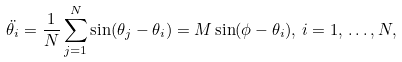<formula> <loc_0><loc_0><loc_500><loc_500>\ddot { \theta _ { i } } = \frac { 1 } { N } \sum _ { j = 1 } ^ { N } \sin ( \theta _ { j } - \theta _ { i } ) = M \sin ( \phi - \theta _ { i } ) , \, i = 1 , \, \dots , N ,</formula> 